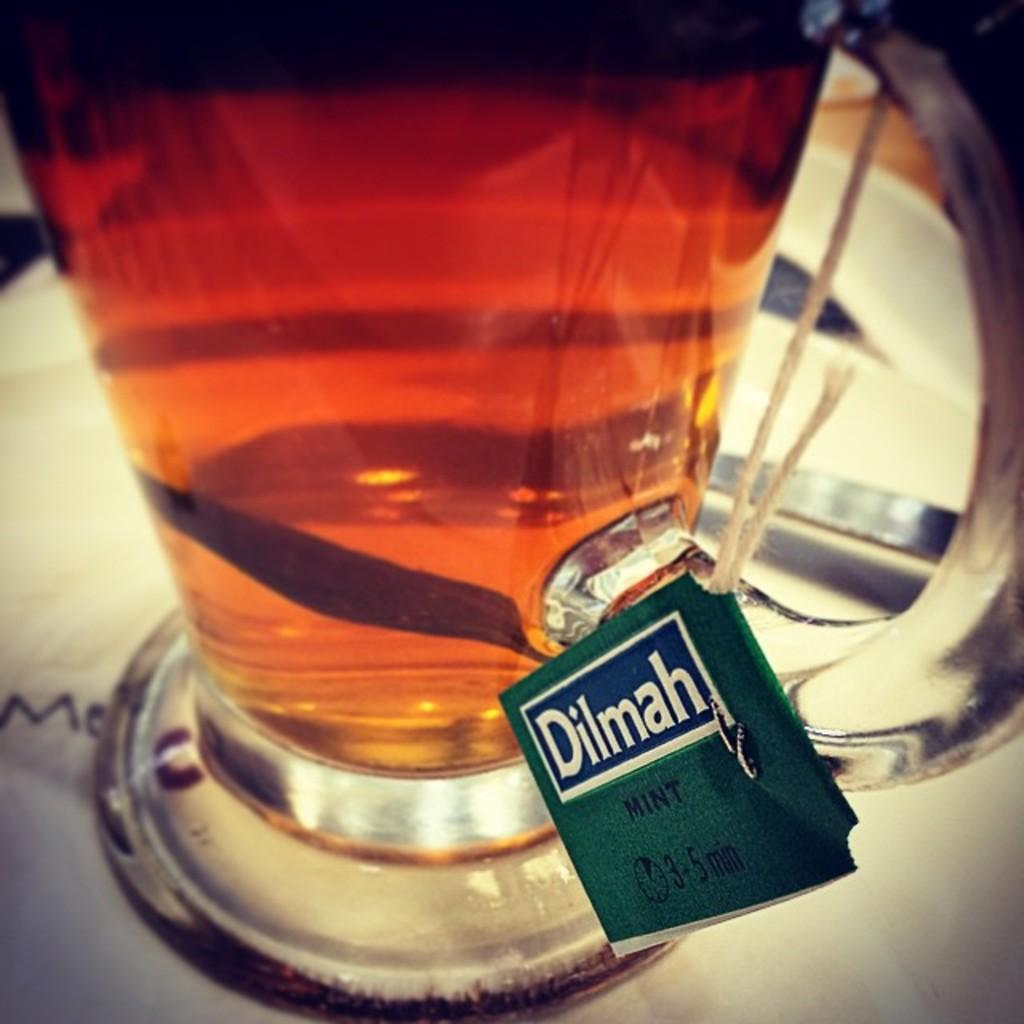What is in the teacup that is visible in the image? The teacup contains a tea bag in the image. What else can be seen in the image besides the teacup? There is a spoon in the image. Where is the spoon located in the image? The spoon is on a plate in the image. How many friends are present in the image? There is no indication of any friends in the image; it only features a teacup, a tea bag, and a spoon. What type of feast is being prepared in the image? There is no feast being prepared in the image; it only features a teacup, a tea bag, and a spoon. 